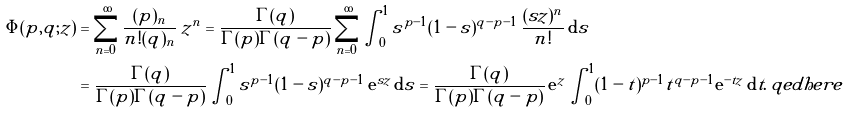<formula> <loc_0><loc_0><loc_500><loc_500>\Phi ( p , q ; z ) & = \sum _ { n = 0 } ^ { \infty } \frac { ( p ) _ { n } } { n ! ( q ) _ { n } } \, z ^ { n } = \frac { \Gamma ( q ) } { \Gamma ( p ) \Gamma ( q - p ) } \sum _ { n = 0 } ^ { \infty } \int _ { 0 } ^ { 1 } s ^ { p - 1 } ( 1 - s ) ^ { q - p - 1 } \, \frac { ( s z ) ^ { n } } { n ! } \, \mathrm d s \\ & = \frac { \Gamma ( q ) } { \Gamma ( p ) \Gamma ( q - p ) } \int _ { 0 } ^ { 1 } s ^ { p - 1 } ( 1 - s ) ^ { q - p - 1 } \, \mathrm e ^ { s z } \, \mathrm d s = \frac { \Gamma ( q ) } { \Gamma ( p ) \Gamma ( q - p ) } \, \mathrm e ^ { z } \int _ { 0 } ^ { 1 } ( 1 - t ) ^ { p - 1 } t ^ { q - p - 1 } \mathrm e ^ { - t z } \, \mathrm d t . \ q e d h e r e</formula> 